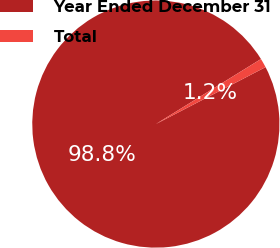<chart> <loc_0><loc_0><loc_500><loc_500><pie_chart><fcel>Year Ended December 31<fcel>Total<nl><fcel>98.8%<fcel>1.2%<nl></chart> 